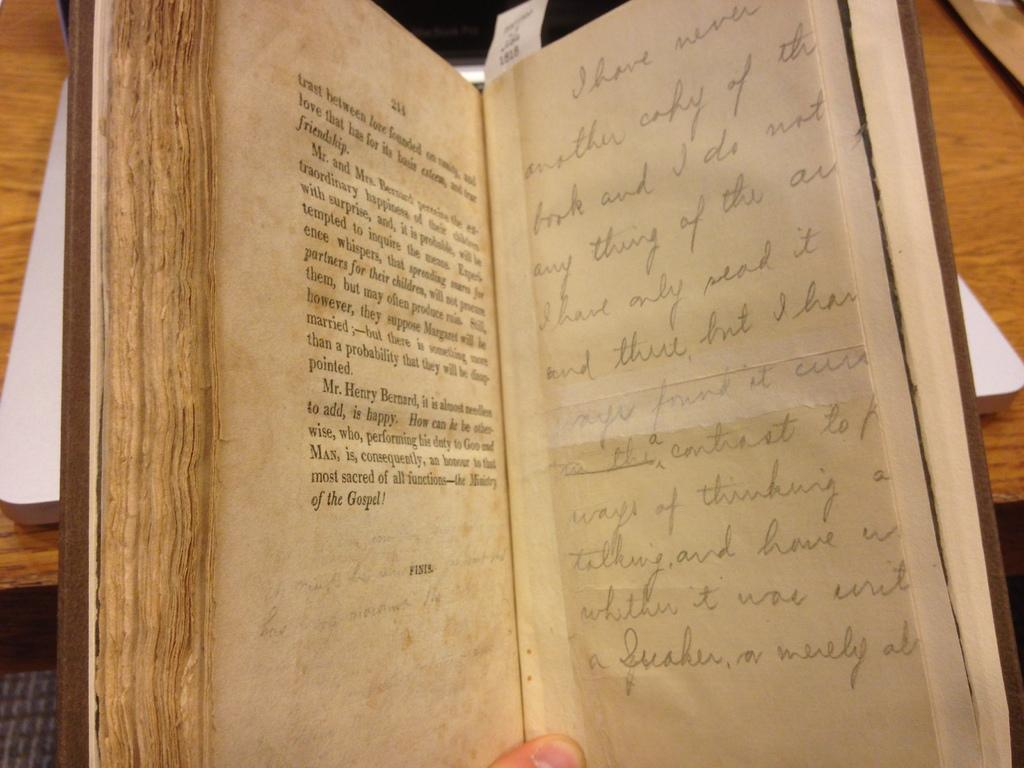Provide a one-sentence caption for the provided image. The book is opened to the pages of 211 and 212. 